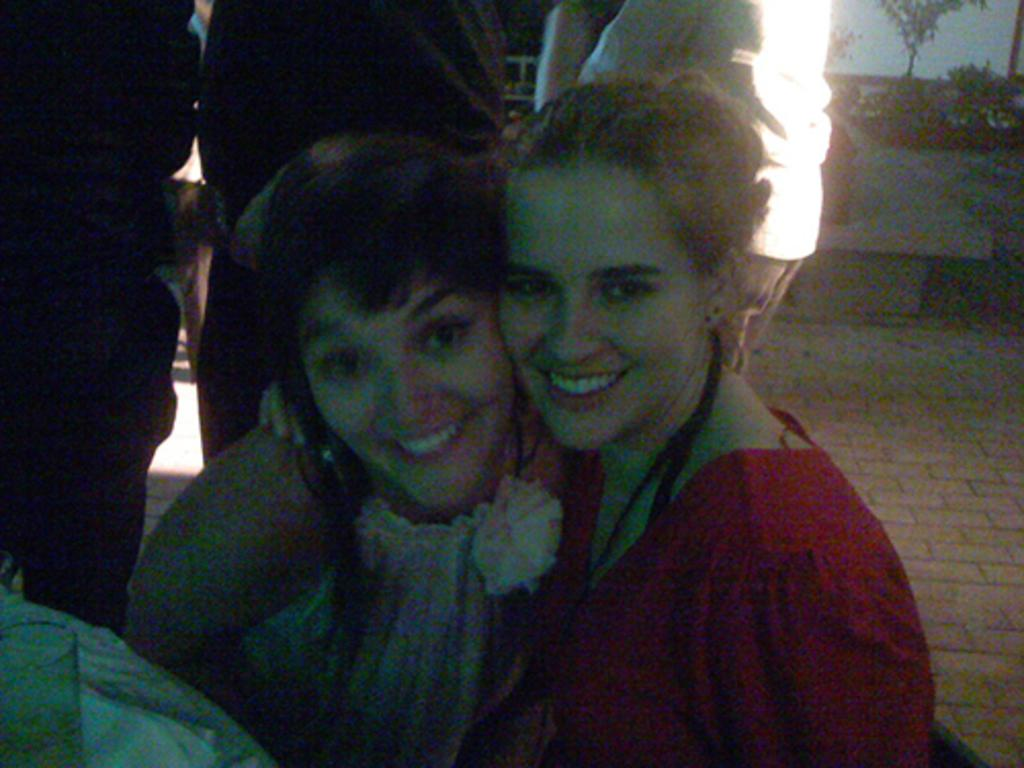How many women are in the image? There are two women in the image. What are the women doing in the image? The women are smiling and posing for a picture. Can you describe the background of the image? There are people in the background of the image. What is located on the right side of the image? There is a bench and trees on the right side of the image. What type of wound can be seen on the tiger in the image? There is no tiger present in the image, and therefore no wound can be observed. 